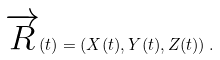<formula> <loc_0><loc_0><loc_500><loc_500>\overrightarrow { R } ( t ) = ( X ( t ) , Y ( t ) , Z ( t ) ) \, .</formula> 